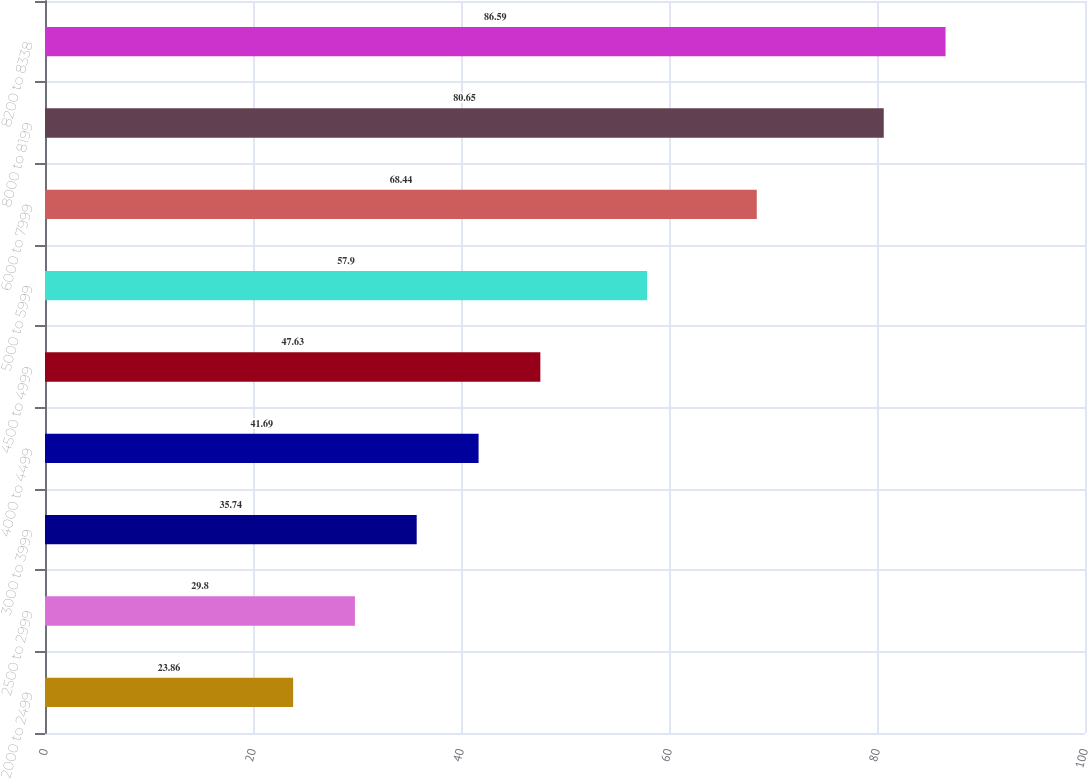Convert chart to OTSL. <chart><loc_0><loc_0><loc_500><loc_500><bar_chart><fcel>2000 to 2499<fcel>2500 to 2999<fcel>3000 to 3999<fcel>4000 to 4499<fcel>4500 to 4999<fcel>5000 to 5999<fcel>6000 to 7999<fcel>8000 to 8199<fcel>8200 to 8338<nl><fcel>23.86<fcel>29.8<fcel>35.74<fcel>41.69<fcel>47.63<fcel>57.9<fcel>68.44<fcel>80.65<fcel>86.59<nl></chart> 